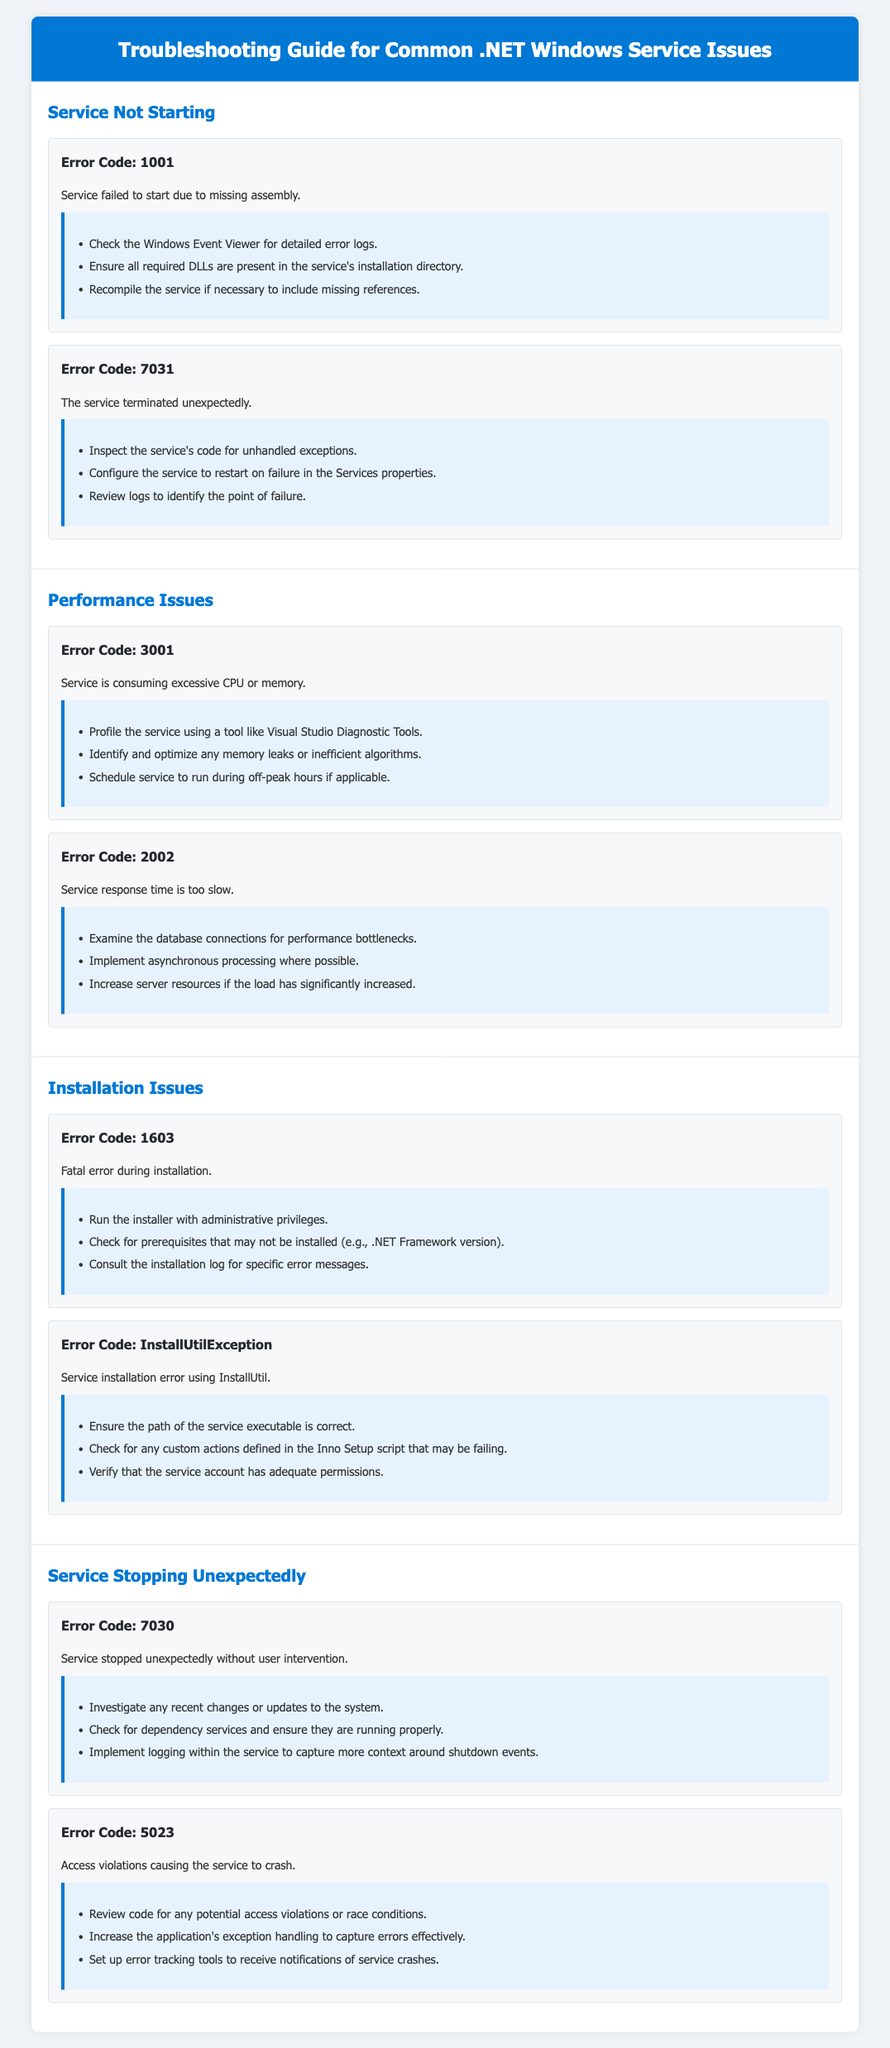What is Error Code 1001? Error Code 1001 indicates a service failed to start due to missing assembly as detailed in the document.
Answer: missing assembly What is one step to resolve Error Code 1603? One resolution step for Error Code 1603, which is a fatal error during installation, is to run the installer with administrative privileges.
Answer: administrative privileges Which section includes Error Code 7030? Error Code 7030 is found under the "Service Stopping Unexpectedly" section of the document.
Answer: Service Stopping Unexpectedly What does the error code 2002 indicate? Error Code 2002 indicates that the service response time is too slow as described in the performance issues section.
Answer: response time is too slow What is a recommended action for services consuming excessive CPU? Profiling the service using a tool like Visual Studio Diagnostic Tools is a recommended action for services consuming excessive CPU.
Answer: Visual Studio Diagnostic Tools 